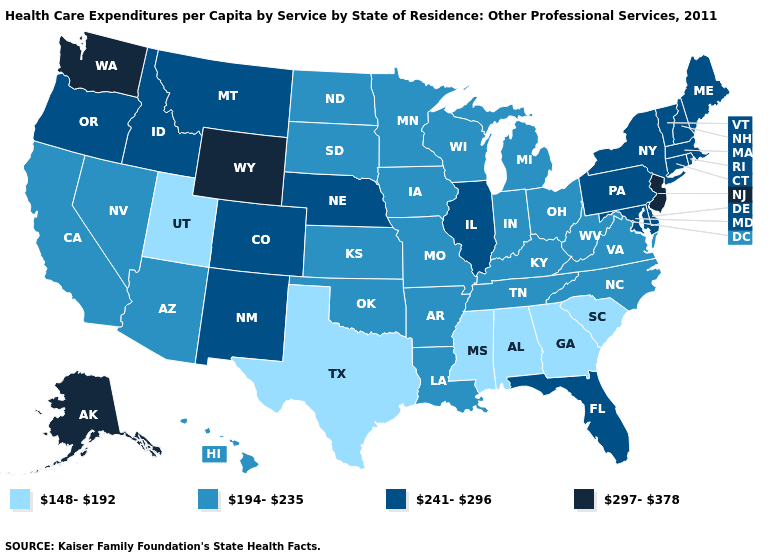Which states have the lowest value in the USA?
Short answer required. Alabama, Georgia, Mississippi, South Carolina, Texas, Utah. What is the lowest value in the USA?
Give a very brief answer. 148-192. Which states hav the highest value in the MidWest?
Keep it brief. Illinois, Nebraska. Among the states that border Delaware , which have the highest value?
Give a very brief answer. New Jersey. Which states have the highest value in the USA?
Give a very brief answer. Alaska, New Jersey, Washington, Wyoming. Among the states that border Arizona , does Utah have the highest value?
Keep it brief. No. Name the states that have a value in the range 148-192?
Keep it brief. Alabama, Georgia, Mississippi, South Carolina, Texas, Utah. Name the states that have a value in the range 148-192?
Answer briefly. Alabama, Georgia, Mississippi, South Carolina, Texas, Utah. Does Alabama have the lowest value in the USA?
Answer briefly. Yes. What is the value of Colorado?
Short answer required. 241-296. What is the value of Georgia?
Write a very short answer. 148-192. What is the lowest value in states that border New Mexico?
Short answer required. 148-192. Which states have the highest value in the USA?
Answer briefly. Alaska, New Jersey, Washington, Wyoming. What is the highest value in the Northeast ?
Concise answer only. 297-378. Name the states that have a value in the range 194-235?
Short answer required. Arizona, Arkansas, California, Hawaii, Indiana, Iowa, Kansas, Kentucky, Louisiana, Michigan, Minnesota, Missouri, Nevada, North Carolina, North Dakota, Ohio, Oklahoma, South Dakota, Tennessee, Virginia, West Virginia, Wisconsin. 